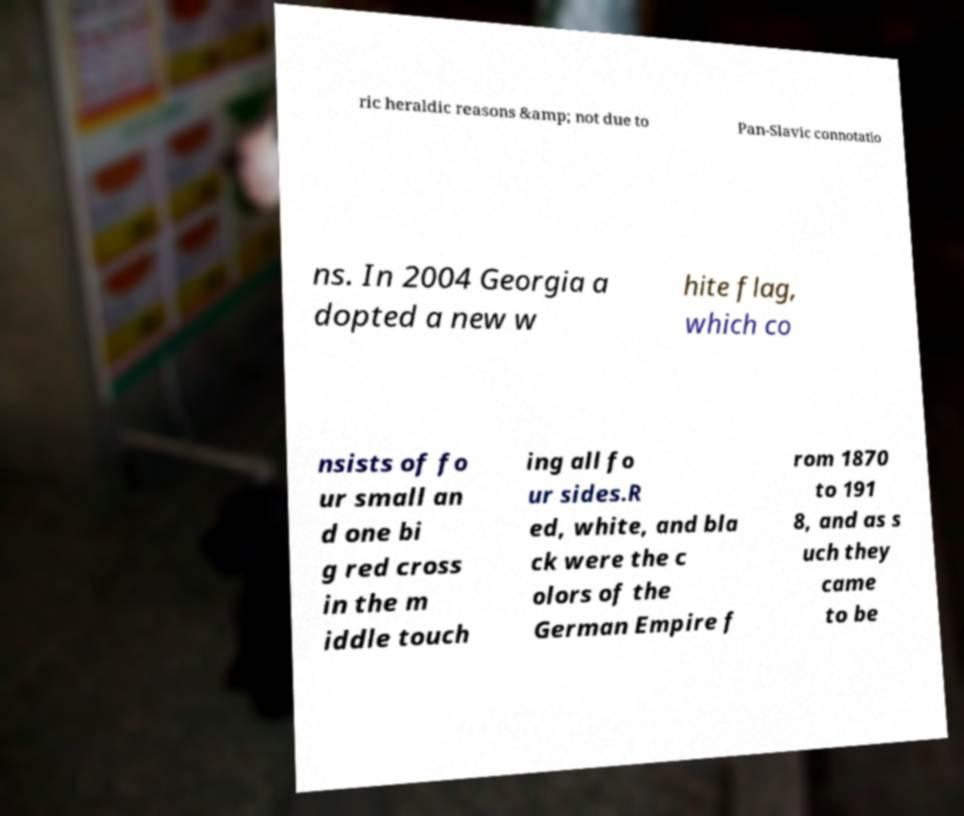Could you extract and type out the text from this image? ric heraldic reasons &amp; not due to Pan-Slavic connotatio ns. In 2004 Georgia a dopted a new w hite flag, which co nsists of fo ur small an d one bi g red cross in the m iddle touch ing all fo ur sides.R ed, white, and bla ck were the c olors of the German Empire f rom 1870 to 191 8, and as s uch they came to be 